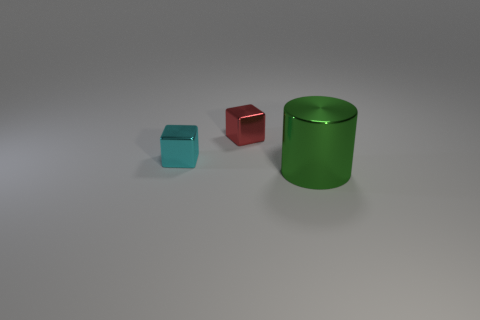What can you infer about the setting of these objects? The objects are placed on a matte surface that suggests an indoor environment, perhaps for a display or an illustrative purpose. The neutral background and soft lighting are typically used to focus attention on the objects themselves, indicating a controlled setting like a studio. 